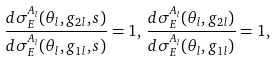<formula> <loc_0><loc_0><loc_500><loc_500>\frac { d \sigma _ { E } ^ { A _ { l } } ( \theta _ { l } , g _ { 2 l } , s ) } { d \sigma _ { E } ^ { A _ { l } } ( \theta _ { l } , g _ { 1 l } , s ) } = 1 , \, \frac { d \sigma _ { E } ^ { A _ { l } } ( \theta _ { l } , g _ { 2 l } ) } { d \sigma _ { E } ^ { A _ { l } } ( \theta _ { l } , g _ { 1 l } ) } = 1 ,</formula> 